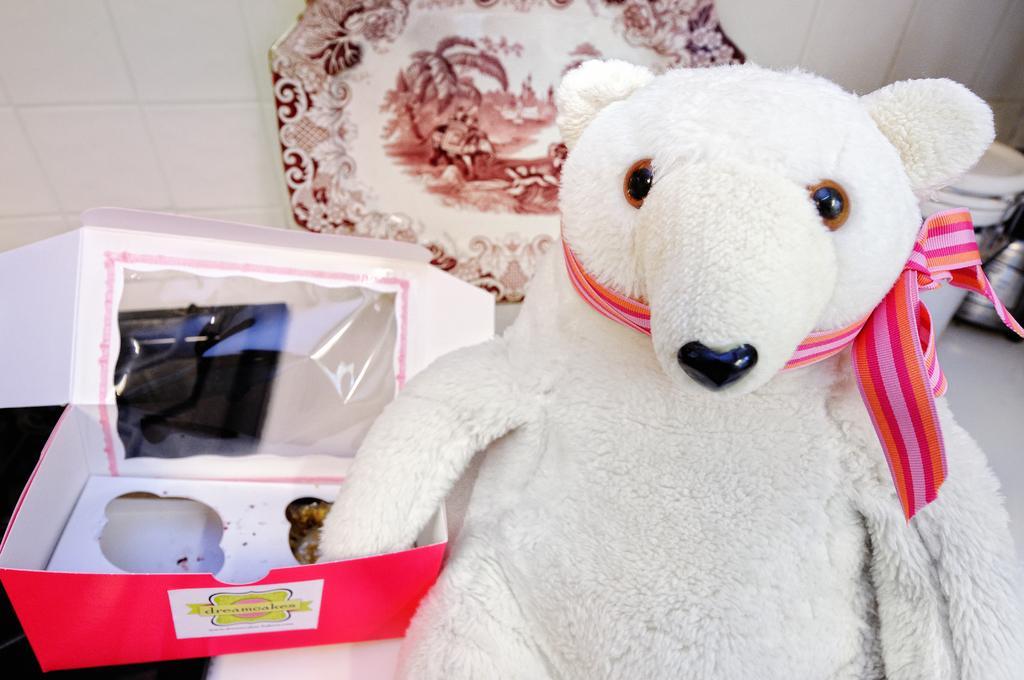Please provide a concise description of this image. In this image I can see the toy and the toy is in white color and I can see a ribbon which is in pink and orange color. Background I can see a cardboard box and I can also see few objects and the wall is in white color. 